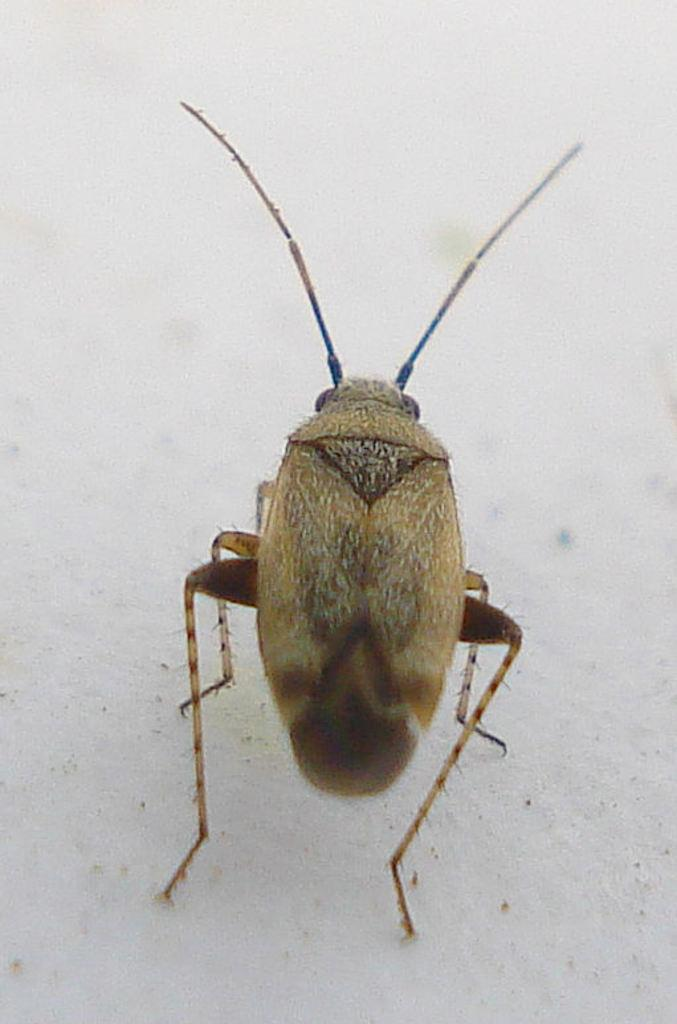What type of creature can be seen in the image? There is an insect in the image. What can be seen in the background of the image? There is a wall visible in the background of the image. What type of income does the insect have in the image? There is no information about the insect's income in the image. Is the insect wearing any underwear in the image? Insects do not wear underwear, and there is no indication of clothing in the image. 